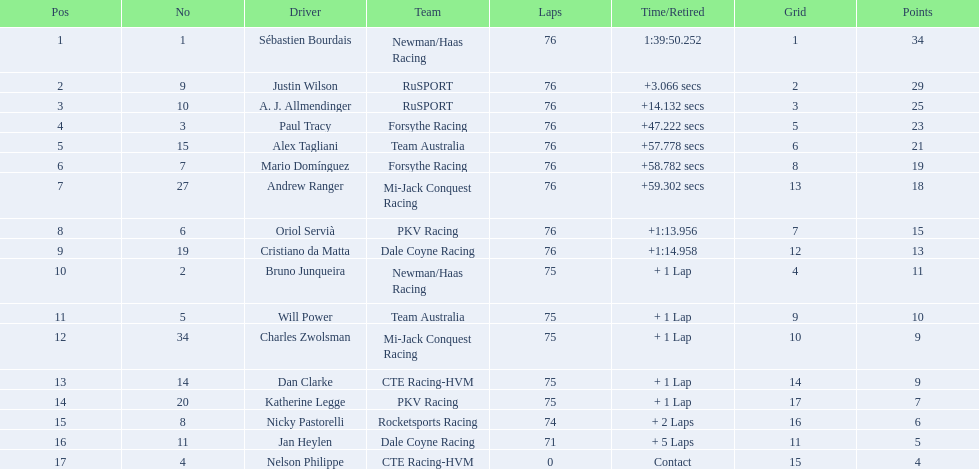Which drivers managed to finish the entire 76 laps? Sébastien Bourdais, Justin Wilson, A. J. Allmendinger, Paul Tracy, Alex Tagliani, Mario Domínguez, Andrew Ranger, Oriol Servià, Cristiano da Matta. Out of these, who were the ones that completed the race within a minute from the first-place driver? Paul Tracy, Alex Tagliani, Mario Domínguez, Andrew Ranger. And from that group, who were the ones that came in less than 50 seconds behind the winner? Justin Wilson, A. J. Allmendinger, Paul Tracy. Of these three drivers, who was the last to finish? Paul Tracy. 